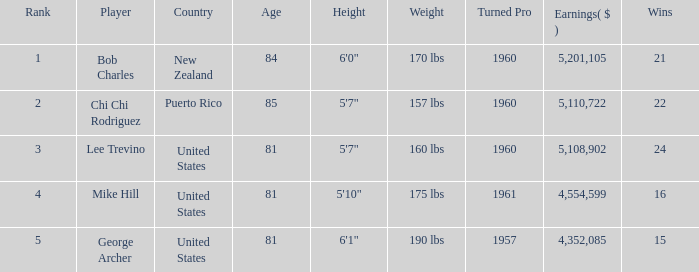On average, how many wins have a rank lower than 1? None. 